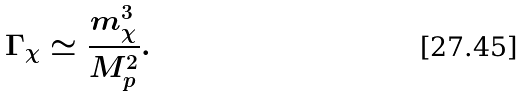<formula> <loc_0><loc_0><loc_500><loc_500>\Gamma _ { \chi } \simeq \frac { m _ { \chi } ^ { 3 } } { M _ { p } ^ { 2 } } .</formula> 